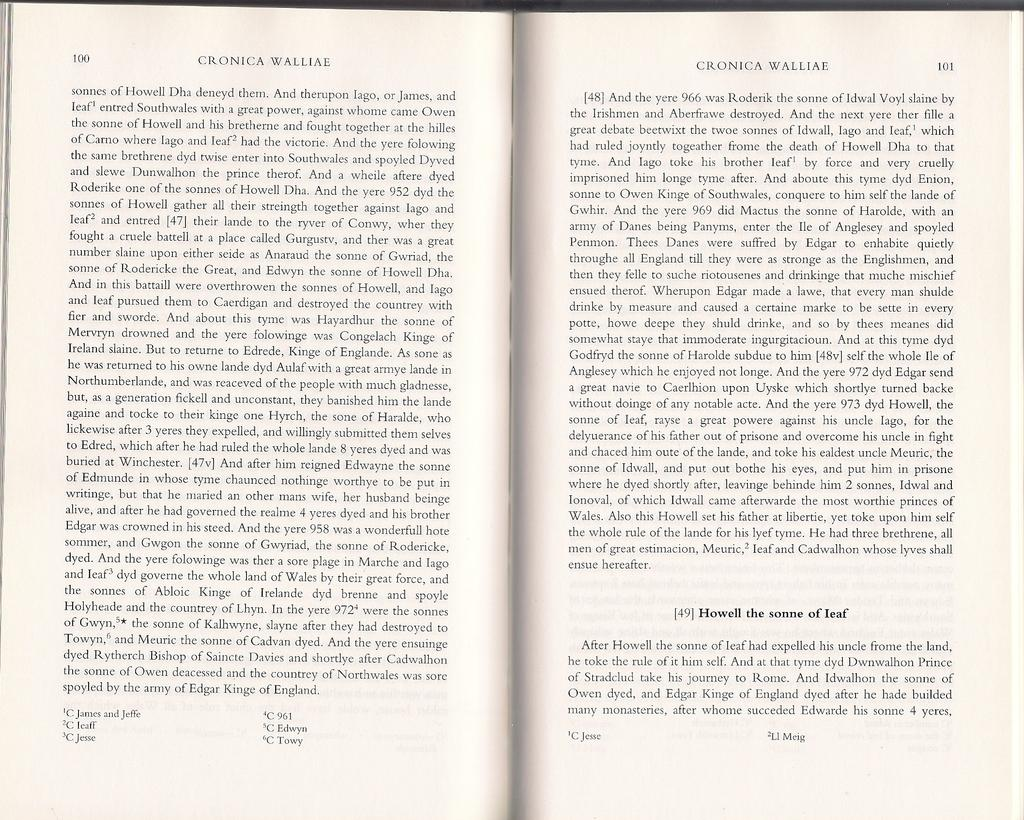<image>
Describe the image concisely. A book by Cronica Walliae opened to pages 100 and 101. 